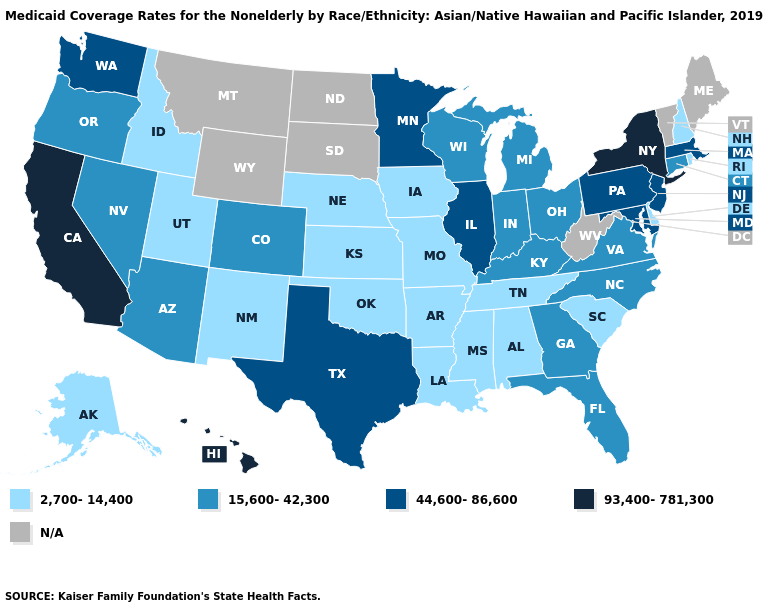Name the states that have a value in the range 2,700-14,400?
Give a very brief answer. Alabama, Alaska, Arkansas, Delaware, Idaho, Iowa, Kansas, Louisiana, Mississippi, Missouri, Nebraska, New Hampshire, New Mexico, Oklahoma, Rhode Island, South Carolina, Tennessee, Utah. What is the value of California?
Short answer required. 93,400-781,300. Name the states that have a value in the range N/A?
Answer briefly. Maine, Montana, North Dakota, South Dakota, Vermont, West Virginia, Wyoming. Does the map have missing data?
Concise answer only. Yes. Is the legend a continuous bar?
Short answer required. No. What is the lowest value in states that border New York?
Write a very short answer. 15,600-42,300. What is the lowest value in the USA?
Write a very short answer. 2,700-14,400. What is the lowest value in the USA?
Give a very brief answer. 2,700-14,400. Which states have the lowest value in the USA?
Be succinct. Alabama, Alaska, Arkansas, Delaware, Idaho, Iowa, Kansas, Louisiana, Mississippi, Missouri, Nebraska, New Hampshire, New Mexico, Oklahoma, Rhode Island, South Carolina, Tennessee, Utah. What is the value of Kentucky?
Write a very short answer. 15,600-42,300. Among the states that border Minnesota , does Iowa have the highest value?
Concise answer only. No. Name the states that have a value in the range 93,400-781,300?
Be succinct. California, Hawaii, New York. 